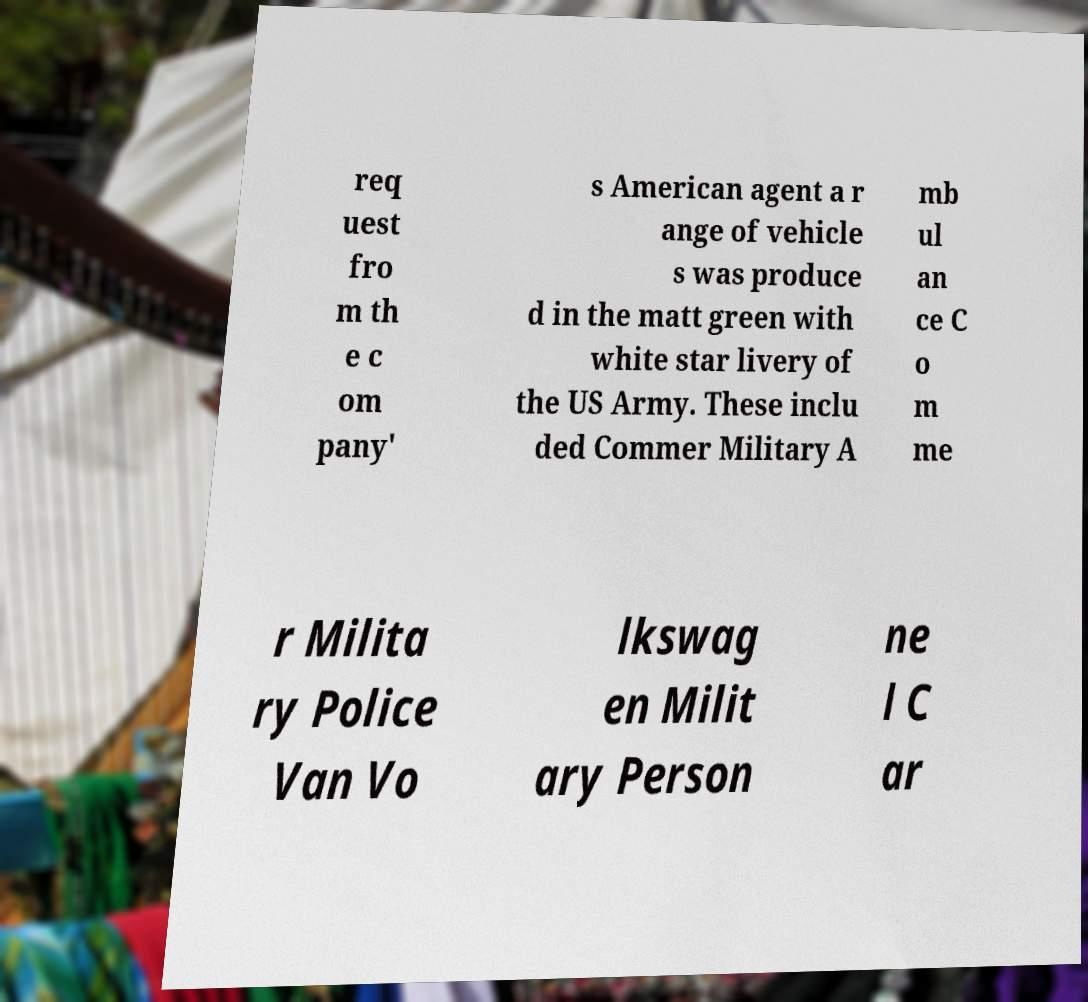What messages or text are displayed in this image? I need them in a readable, typed format. req uest fro m th e c om pany' s American agent a r ange of vehicle s was produce d in the matt green with white star livery of the US Army. These inclu ded Commer Military A mb ul an ce C o m me r Milita ry Police Van Vo lkswag en Milit ary Person ne l C ar 